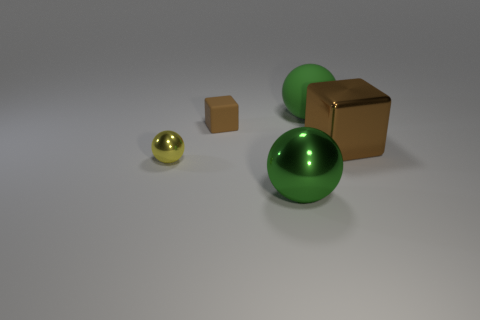Subtract all green spheres. How many were subtracted if there are1green spheres left? 1 Subtract 1 balls. How many balls are left? 2 Add 1 tiny brown blocks. How many objects exist? 6 Subtract all spheres. How many objects are left? 2 Subtract all green matte balls. Subtract all brown matte cubes. How many objects are left? 3 Add 5 small metallic balls. How many small metallic balls are left? 6 Add 1 small balls. How many small balls exist? 2 Subtract 0 gray spheres. How many objects are left? 5 